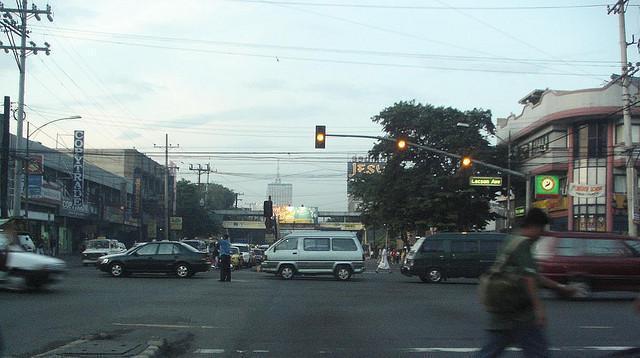How many cars are there?
Give a very brief answer. 4. How many chocolate donuts are there?
Give a very brief answer. 0. 